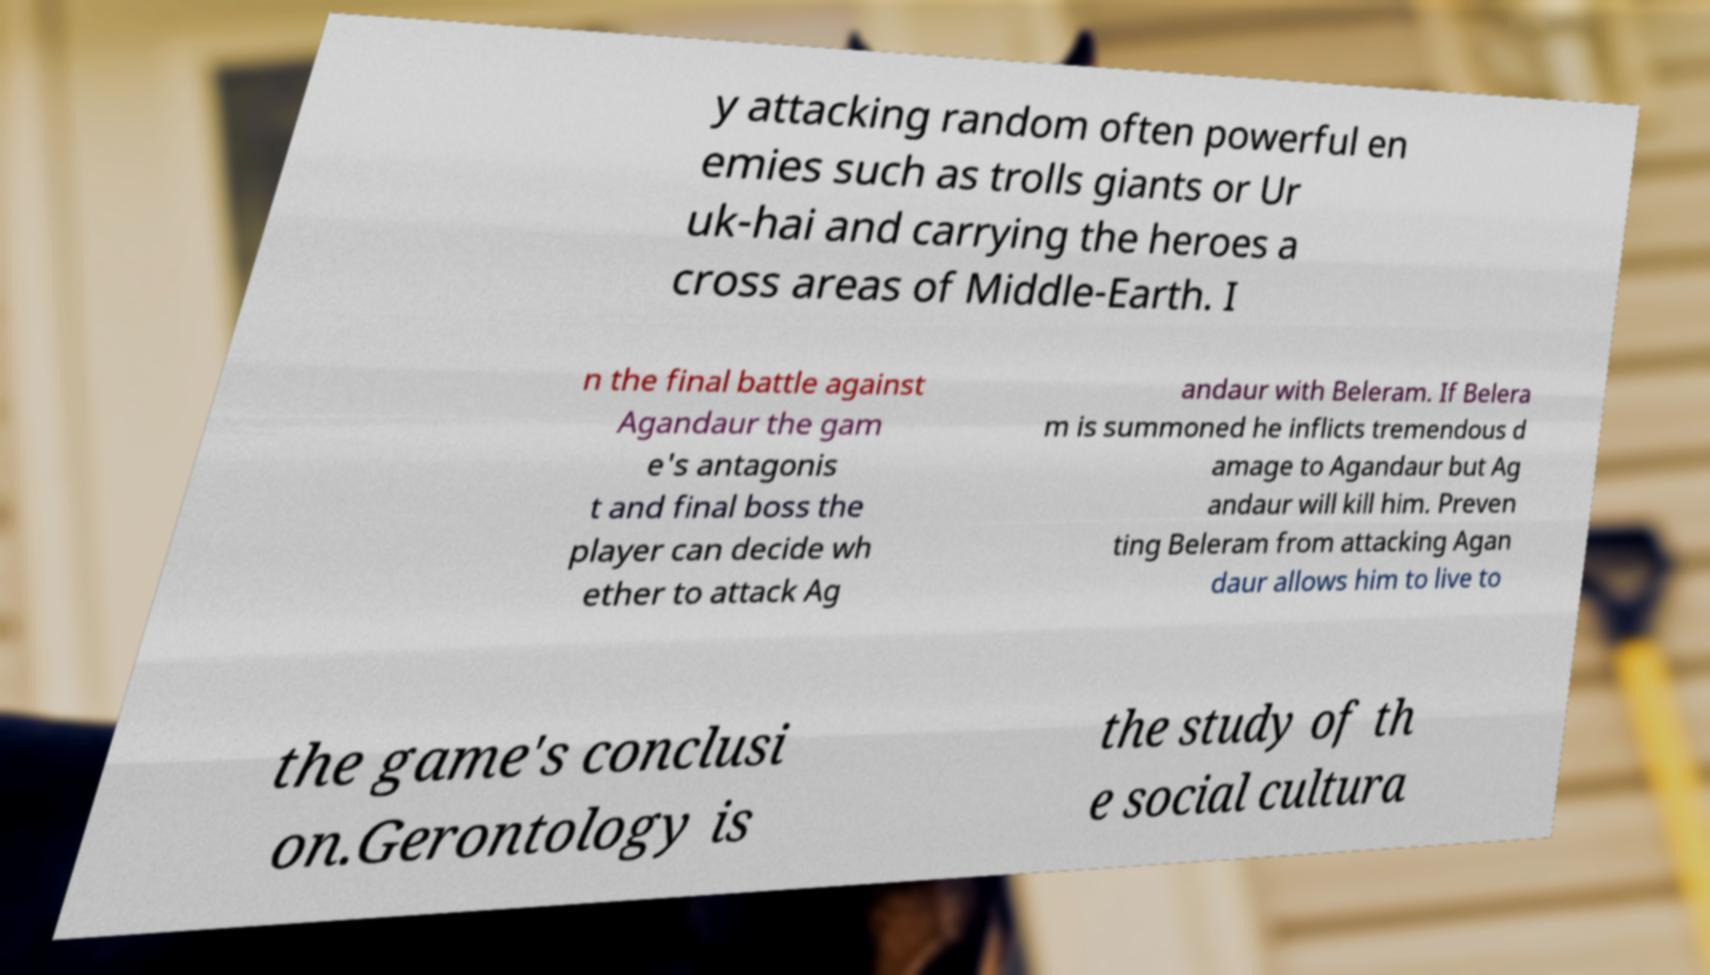For documentation purposes, I need the text within this image transcribed. Could you provide that? y attacking random often powerful en emies such as trolls giants or Ur uk-hai and carrying the heroes a cross areas of Middle-Earth. I n the final battle against Agandaur the gam e's antagonis t and final boss the player can decide wh ether to attack Ag andaur with Beleram. If Belera m is summoned he inflicts tremendous d amage to Agandaur but Ag andaur will kill him. Preven ting Beleram from attacking Agan daur allows him to live to the game's conclusi on.Gerontology is the study of th e social cultura 